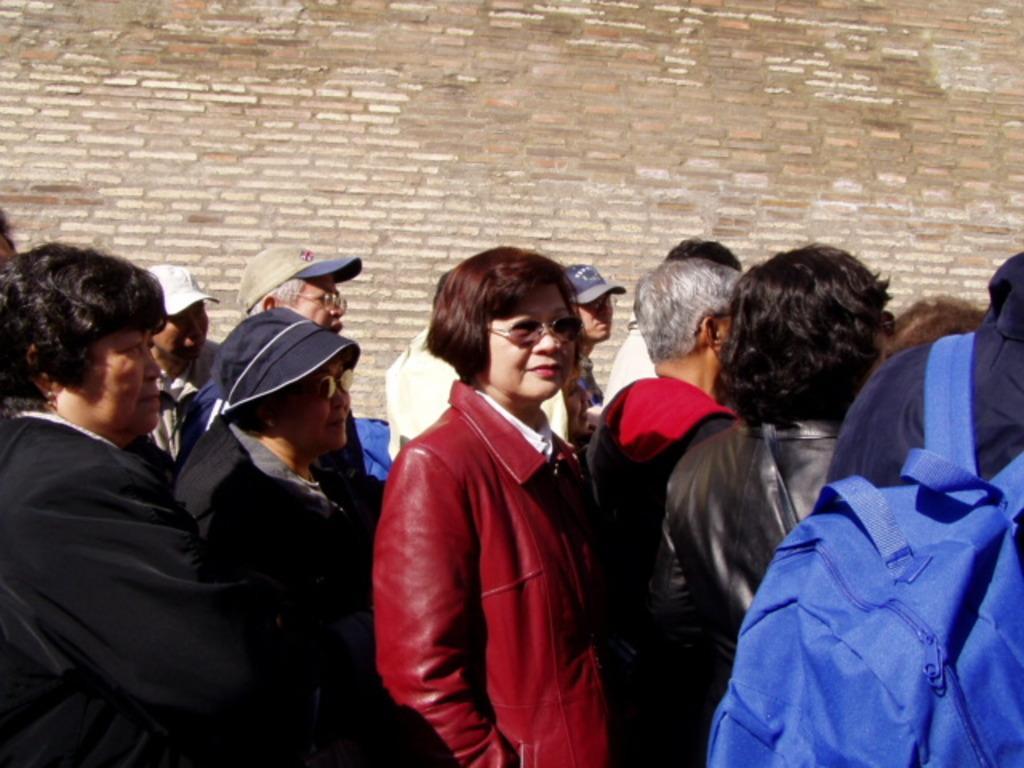Please provide a concise description of this image. In this picture we can see a group of people standing on the path. Behind the people there is a wall. 